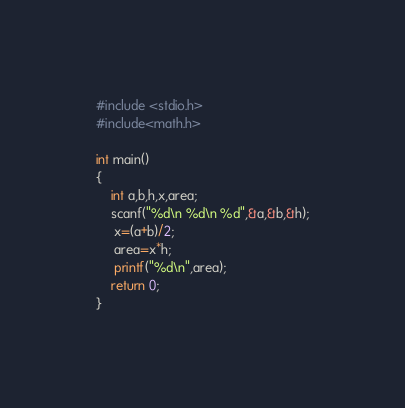Convert code to text. <code><loc_0><loc_0><loc_500><loc_500><_Awk_>#include <stdio.h>
#include<math.h>

int main()
{
    int a,b,h,x,area;
    scanf("%d\n %d\n %d",&a,&b,&h);
     x=(a+b)/2;
     area=x*h;
     printf("%d\n",area);
    return 0;
}
</code> 